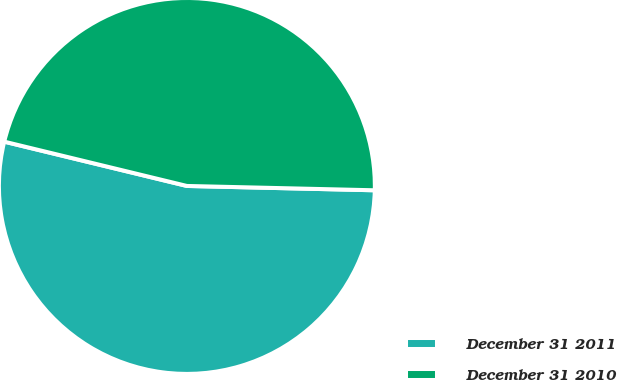<chart> <loc_0><loc_0><loc_500><loc_500><pie_chart><fcel>December 31 2011<fcel>December 31 2010<nl><fcel>53.42%<fcel>46.58%<nl></chart> 